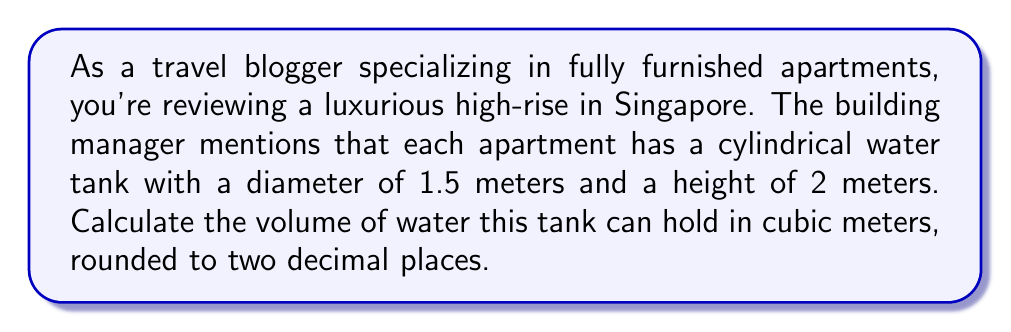Provide a solution to this math problem. To solve this problem, we need to use the formula for the volume of a cylinder:

$$V = \pi r^2 h$$

Where:
$V$ = volume
$r$ = radius of the base
$h$ = height of the cylinder

Let's break it down step by step:

1. Identify the given dimensions:
   - Diameter = 1.5 meters
   - Height = 2 meters

2. Calculate the radius:
   $r = \frac{\text{diameter}}{2} = \frac{1.5}{2} = 0.75$ meters

3. Apply the volume formula:
   $$V = \pi (0.75)^2 (2)$$

4. Simplify:
   $$V = \pi (0.5625) (2)$$
   $$V = 1.125\pi$$

5. Calculate the final value (using $\pi \approx 3.14159$):
   $$V \approx 1.125 \times 3.14159 \approx 3.5342875$$

6. Round to two decimal places:
   $$V \approx 3.53 \text{ m}^3$$

[asy]
import geometry;

size(200);
real r = 0.75;
real h = 2;

path p = circle((0,0), r);
draw(p);
draw((r,0)--(r,h));
draw((-r,0)--(-r,h));
draw(p, (0,h));

label("r", (r/2,0), S);
label("h", (r,h/2), E);
label("1.5 m", (0,-r-0.2), S);
label("2 m", (r+0.2,h/2), E);

draw((0,0)--(r,0), arrow=Arrow(TeXHead));
draw((r,0)--(r,h), arrow=Arrow(TeXHead));
[/asy]
Answer: The volume of the cylindrical water tank is approximately $3.53 \text{ m}^3$. 